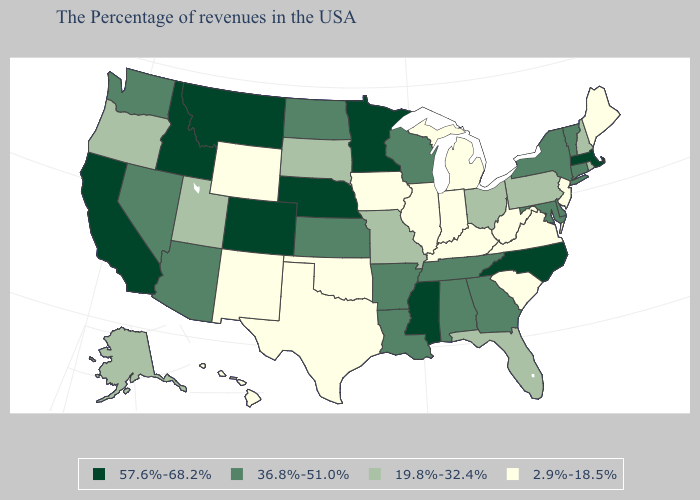What is the value of Tennessee?
Give a very brief answer. 36.8%-51.0%. Name the states that have a value in the range 2.9%-18.5%?
Be succinct. Maine, New Jersey, Virginia, South Carolina, West Virginia, Michigan, Kentucky, Indiana, Illinois, Iowa, Oklahoma, Texas, Wyoming, New Mexico, Hawaii. Does Delaware have a lower value than Colorado?
Keep it brief. Yes. What is the lowest value in the USA?
Be succinct. 2.9%-18.5%. Among the states that border Utah , which have the lowest value?
Give a very brief answer. Wyoming, New Mexico. Name the states that have a value in the range 2.9%-18.5%?
Keep it brief. Maine, New Jersey, Virginia, South Carolina, West Virginia, Michigan, Kentucky, Indiana, Illinois, Iowa, Oklahoma, Texas, Wyoming, New Mexico, Hawaii. Name the states that have a value in the range 36.8%-51.0%?
Give a very brief answer. Vermont, Connecticut, New York, Delaware, Maryland, Georgia, Alabama, Tennessee, Wisconsin, Louisiana, Arkansas, Kansas, North Dakota, Arizona, Nevada, Washington. Does Arkansas have a lower value than Indiana?
Keep it brief. No. Does Missouri have the lowest value in the USA?
Write a very short answer. No. What is the value of Rhode Island?
Write a very short answer. 19.8%-32.4%. Among the states that border Oklahoma , which have the lowest value?
Give a very brief answer. Texas, New Mexico. Is the legend a continuous bar?
Be succinct. No. What is the lowest value in the USA?
Quick response, please. 2.9%-18.5%. What is the value of Alabama?
Answer briefly. 36.8%-51.0%. What is the value of Wyoming?
Short answer required. 2.9%-18.5%. 